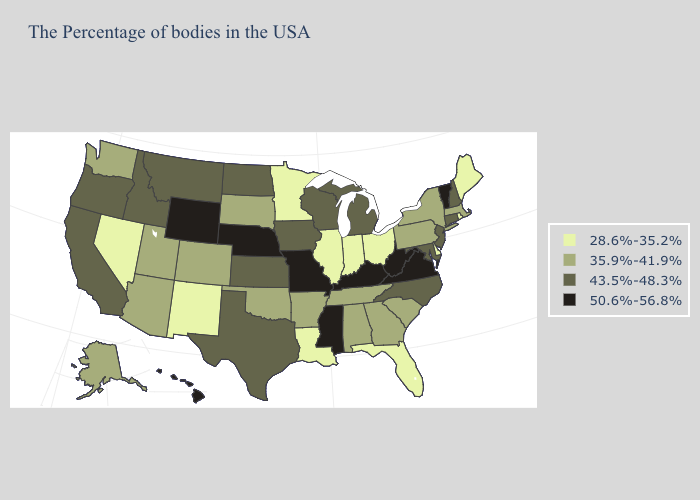Among the states that border Alabama , does Mississippi have the highest value?
Give a very brief answer. Yes. Does Utah have the highest value in the USA?
Be succinct. No. Does Vermont have the highest value in the Northeast?
Write a very short answer. Yes. What is the highest value in states that border Tennessee?
Short answer required. 50.6%-56.8%. Does Virginia have the highest value in the South?
Quick response, please. Yes. Which states have the lowest value in the South?
Write a very short answer. Delaware, Florida, Louisiana. Name the states that have a value in the range 43.5%-48.3%?
Give a very brief answer. New Hampshire, Connecticut, New Jersey, Maryland, North Carolina, Michigan, Wisconsin, Iowa, Kansas, Texas, North Dakota, Montana, Idaho, California, Oregon. Does Delaware have a lower value than New Mexico?
Keep it brief. No. Name the states that have a value in the range 28.6%-35.2%?
Give a very brief answer. Maine, Rhode Island, Delaware, Ohio, Florida, Indiana, Illinois, Louisiana, Minnesota, New Mexico, Nevada. What is the value of Alabama?
Short answer required. 35.9%-41.9%. Among the states that border Nevada , which have the highest value?
Short answer required. Idaho, California, Oregon. Does Missouri have the highest value in the USA?
Write a very short answer. Yes. Among the states that border Wisconsin , does Michigan have the highest value?
Be succinct. Yes. What is the value of Vermont?
Quick response, please. 50.6%-56.8%. What is the highest value in the USA?
Concise answer only. 50.6%-56.8%. 